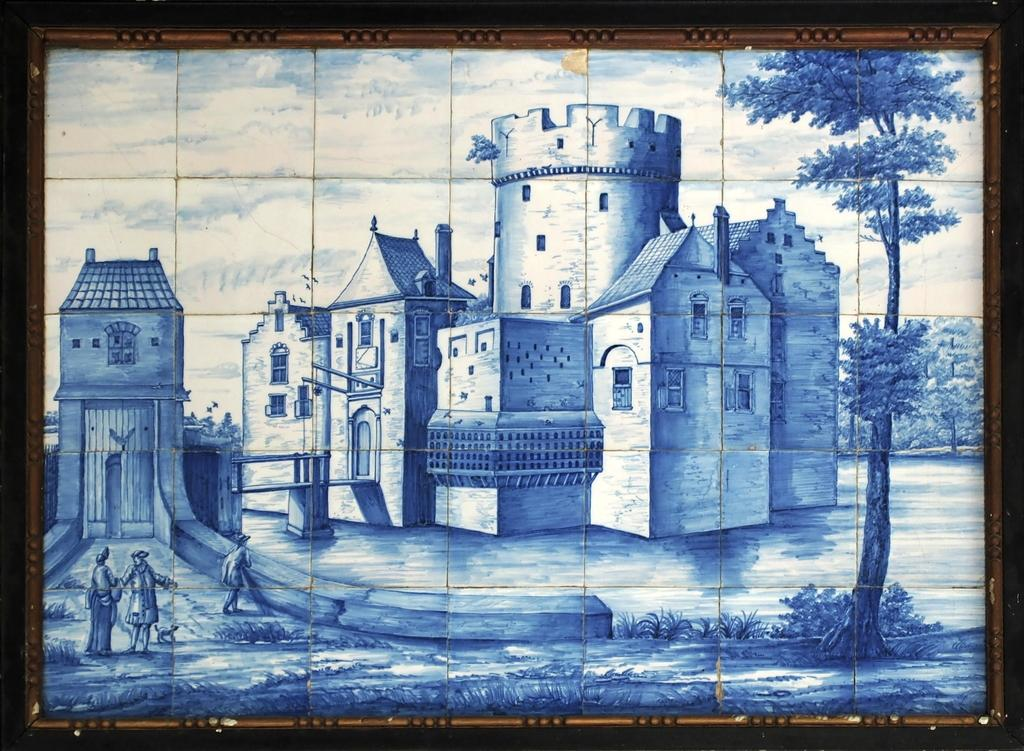What type of object is depicted in the image? The image is an art piece in a photo frame. What does the art piece resemble? The art piece resembles a fort. Where are the three persons located in the image? The three persons are on the left side of the image. What can be seen on the right side of the image? There is a tree on the right side of the image. What type of prose is being recited by the persons in the image? There is no indication in the image that the persons are reciting any prose. Can you tell me how many rocks are visible in the image? There are no rocks visible in the image; it features a fort-like art piece, three persons, and a tree. 